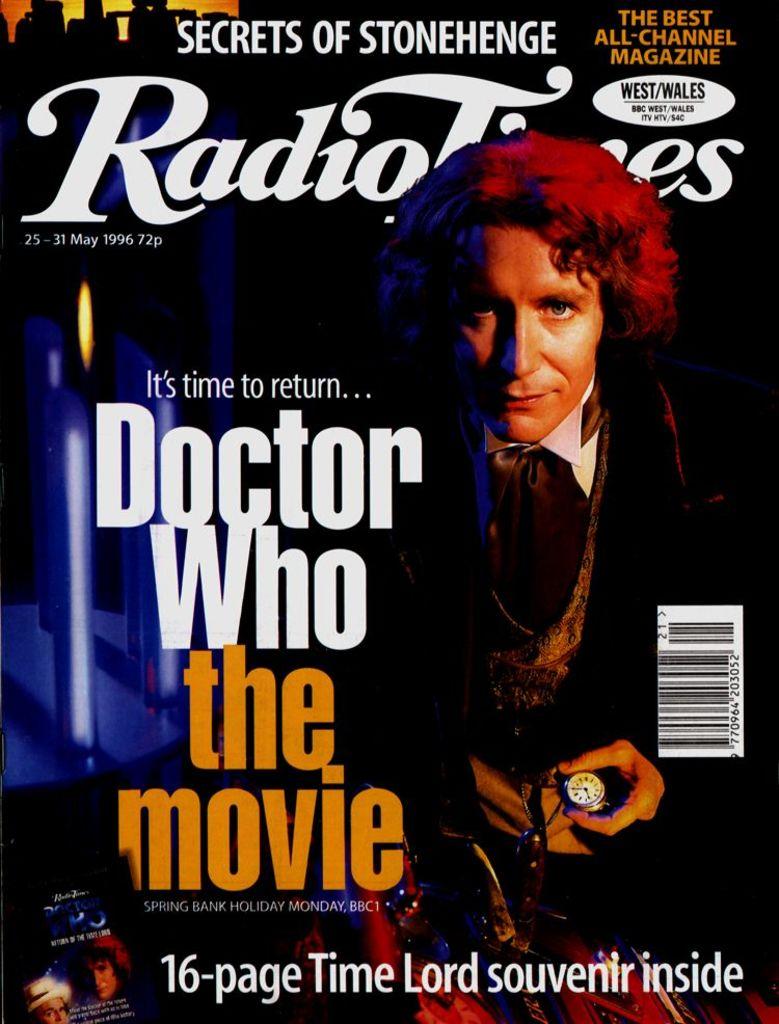What doctor is mentioned?
Make the answer very short. Doctor who. What is the name of the movie?
Keep it short and to the point. Doctor who. 